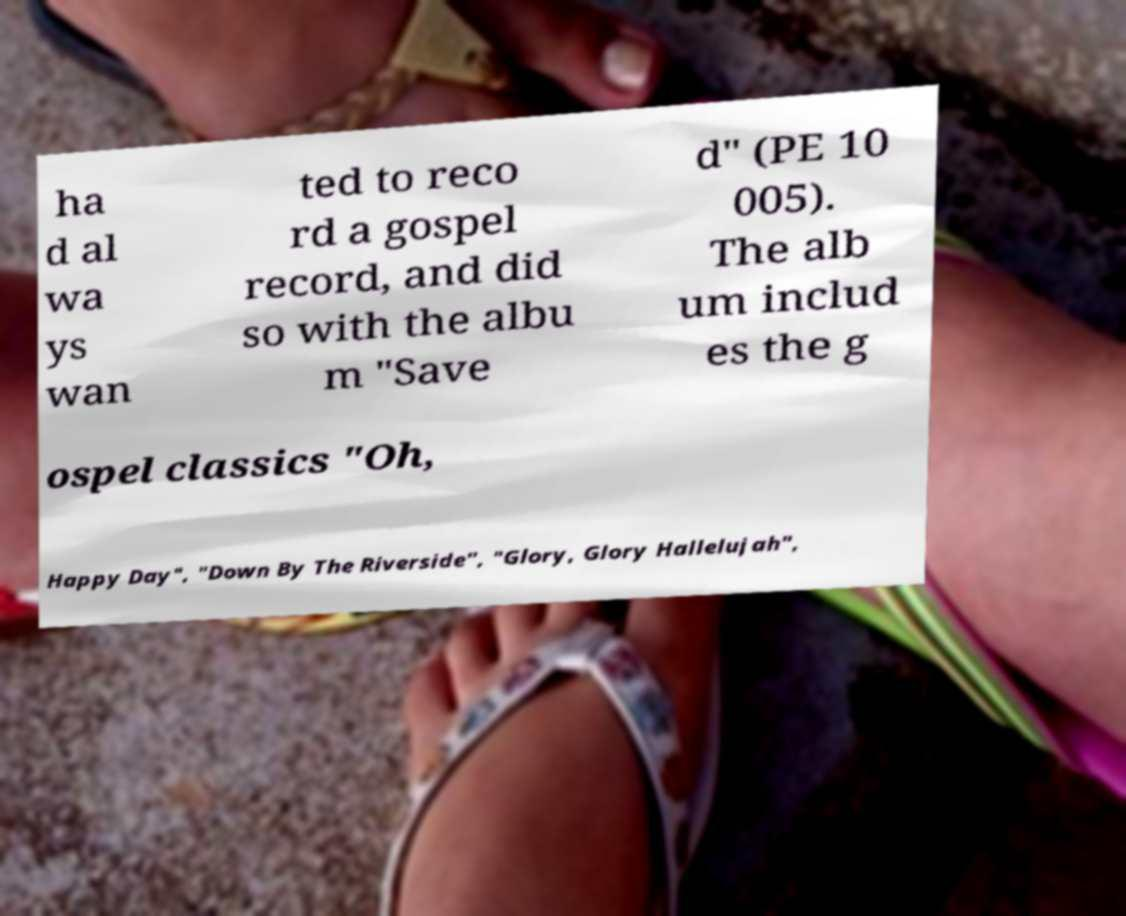Please identify and transcribe the text found in this image. ha d al wa ys wan ted to reco rd a gospel record, and did so with the albu m "Save d" (PE 10 005). The alb um includ es the g ospel classics "Oh, Happy Day", "Down By The Riverside", "Glory, Glory Hallelujah", 